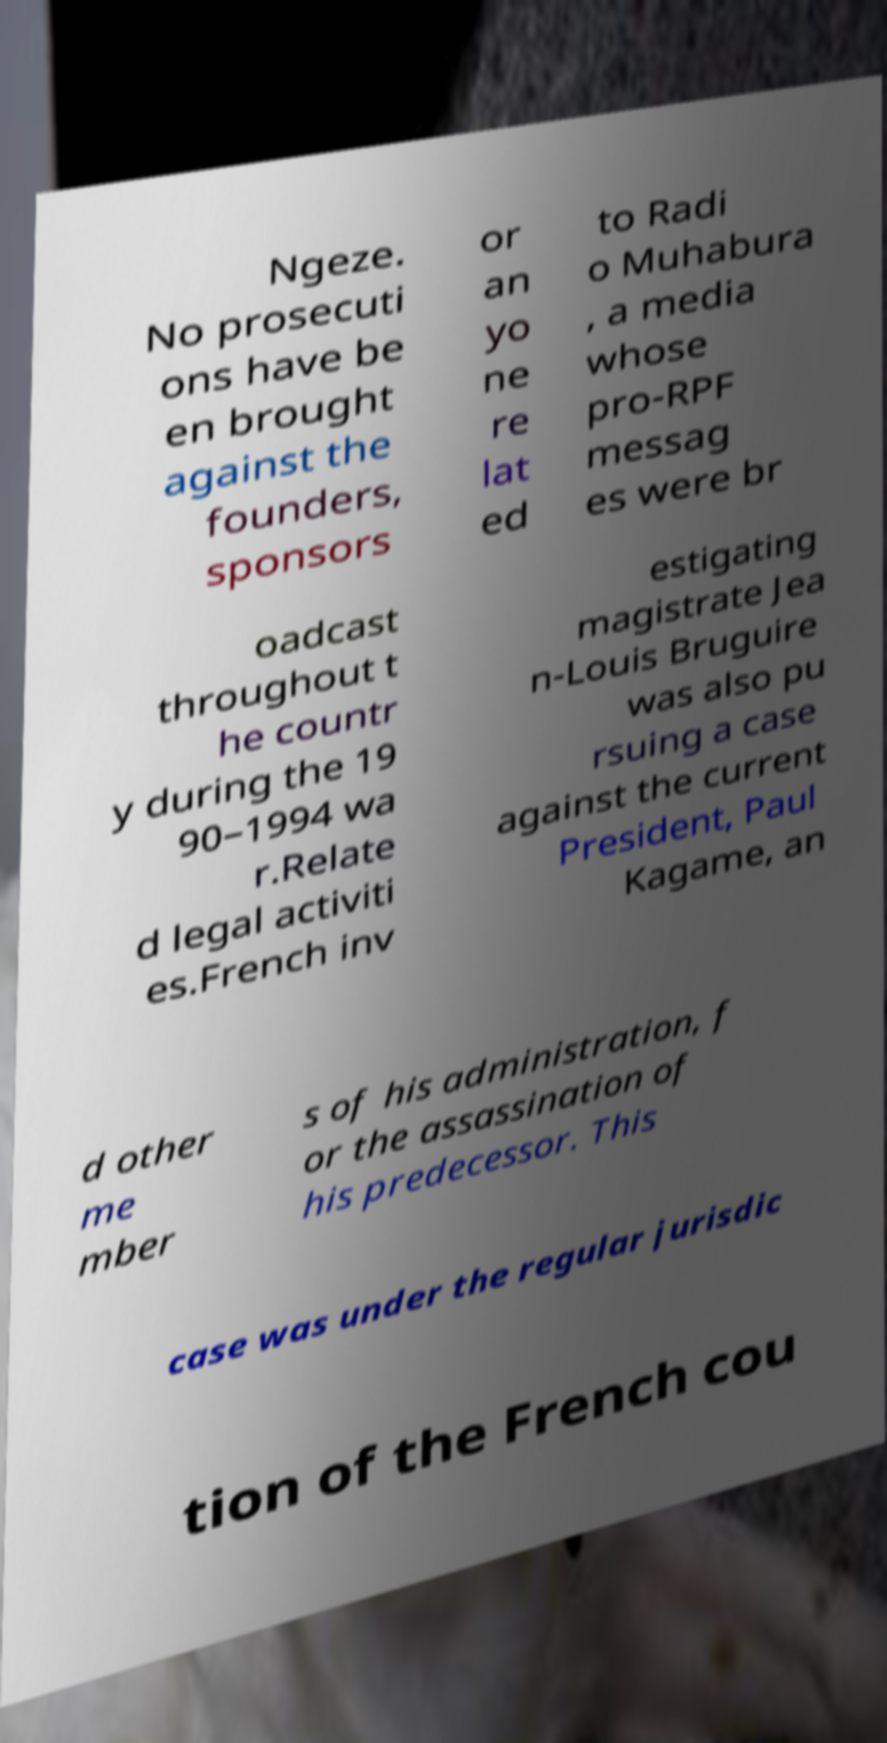There's text embedded in this image that I need extracted. Can you transcribe it verbatim? Ngeze. No prosecuti ons have be en brought against the founders, sponsors or an yo ne re lat ed to Radi o Muhabura , a media whose pro-RPF messag es were br oadcast throughout t he countr y during the 19 90–1994 wa r.Relate d legal activiti es.French inv estigating magistrate Jea n-Louis Bruguire was also pu rsuing a case against the current President, Paul Kagame, an d other me mber s of his administration, f or the assassination of his predecessor. This case was under the regular jurisdic tion of the French cou 